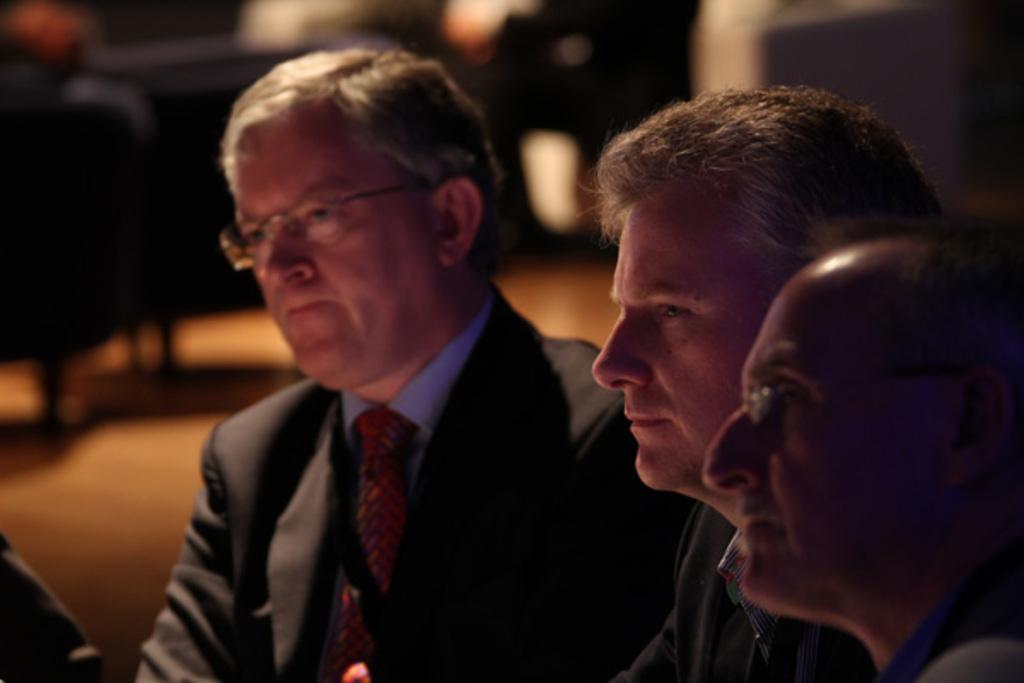How many people are sitting in the image? There are three persons sitting in the image. What is the man in the front wearing? The man in the front is wearing a black suit and a red tie. What can be seen in the background of the image? There are chairs in the background of the image. What is visible beneath the people sitting in the image? There is a floor visible in the image. What musical instrument is the man in the front playing in the image? There is no musical instrument present in the image, and the man in the front is not playing any instrument. 